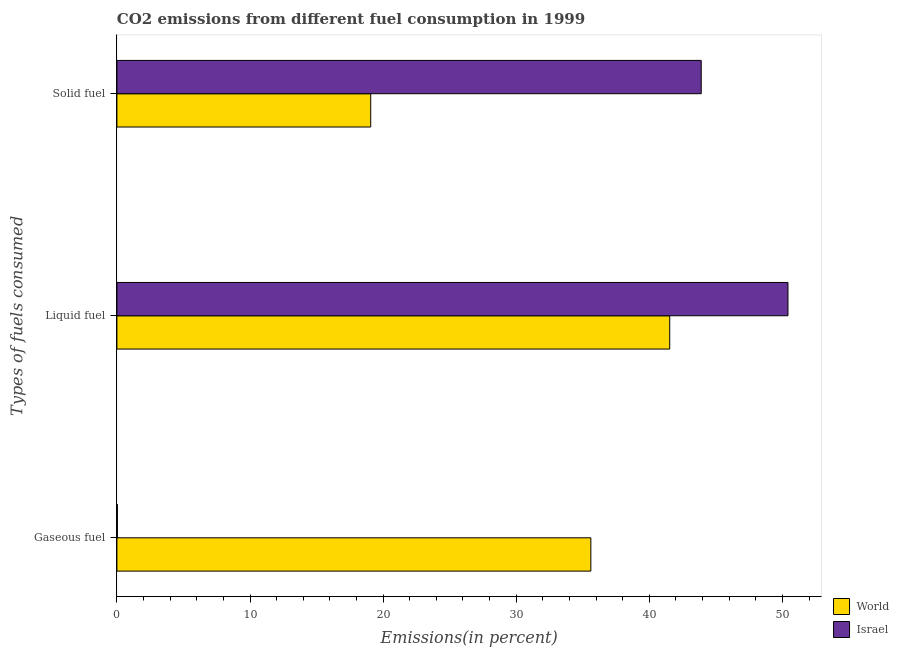How many groups of bars are there?
Offer a very short reply. 3. Are the number of bars per tick equal to the number of legend labels?
Provide a short and direct response. Yes. Are the number of bars on each tick of the Y-axis equal?
Keep it short and to the point. Yes. How many bars are there on the 1st tick from the top?
Make the answer very short. 2. How many bars are there on the 1st tick from the bottom?
Provide a succinct answer. 2. What is the label of the 1st group of bars from the top?
Provide a short and direct response. Solid fuel. What is the percentage of gaseous fuel emission in World?
Your response must be concise. 35.61. Across all countries, what is the maximum percentage of liquid fuel emission?
Give a very brief answer. 50.42. Across all countries, what is the minimum percentage of gaseous fuel emission?
Give a very brief answer. 0.03. In which country was the percentage of solid fuel emission maximum?
Your answer should be compact. Israel. What is the total percentage of gaseous fuel emission in the graph?
Offer a very short reply. 35.64. What is the difference between the percentage of solid fuel emission in World and that in Israel?
Your answer should be very brief. -24.83. What is the difference between the percentage of liquid fuel emission in World and the percentage of gaseous fuel emission in Israel?
Ensure brevity in your answer.  41.5. What is the average percentage of liquid fuel emission per country?
Your response must be concise. 45.98. What is the difference between the percentage of liquid fuel emission and percentage of gaseous fuel emission in Israel?
Ensure brevity in your answer.  50.39. What is the ratio of the percentage of solid fuel emission in Israel to that in World?
Offer a terse response. 2.3. Is the percentage of solid fuel emission in Israel less than that in World?
Your answer should be very brief. No. What is the difference between the highest and the second highest percentage of liquid fuel emission?
Your answer should be compact. 8.88. What is the difference between the highest and the lowest percentage of liquid fuel emission?
Provide a short and direct response. 8.88. In how many countries, is the percentage of solid fuel emission greater than the average percentage of solid fuel emission taken over all countries?
Your answer should be compact. 1. What does the 1st bar from the top in Liquid fuel represents?
Offer a terse response. Israel. What does the 1st bar from the bottom in Gaseous fuel represents?
Your answer should be very brief. World. Is it the case that in every country, the sum of the percentage of gaseous fuel emission and percentage of liquid fuel emission is greater than the percentage of solid fuel emission?
Your answer should be very brief. Yes. Are all the bars in the graph horizontal?
Offer a terse response. Yes. Are the values on the major ticks of X-axis written in scientific E-notation?
Make the answer very short. No. Does the graph contain any zero values?
Keep it short and to the point. No. Does the graph contain grids?
Offer a terse response. No. Where does the legend appear in the graph?
Keep it short and to the point. Bottom right. What is the title of the graph?
Provide a succinct answer. CO2 emissions from different fuel consumption in 1999. Does "Burundi" appear as one of the legend labels in the graph?
Your answer should be very brief. No. What is the label or title of the X-axis?
Offer a terse response. Emissions(in percent). What is the label or title of the Y-axis?
Ensure brevity in your answer.  Types of fuels consumed. What is the Emissions(in percent) of World in Gaseous fuel?
Your answer should be compact. 35.61. What is the Emissions(in percent) of Israel in Gaseous fuel?
Give a very brief answer. 0.03. What is the Emissions(in percent) of World in Liquid fuel?
Keep it short and to the point. 41.53. What is the Emissions(in percent) of Israel in Liquid fuel?
Give a very brief answer. 50.42. What is the Emissions(in percent) of World in Solid fuel?
Your response must be concise. 19.07. What is the Emissions(in percent) of Israel in Solid fuel?
Your answer should be very brief. 43.9. Across all Types of fuels consumed, what is the maximum Emissions(in percent) in World?
Ensure brevity in your answer.  41.53. Across all Types of fuels consumed, what is the maximum Emissions(in percent) in Israel?
Ensure brevity in your answer.  50.42. Across all Types of fuels consumed, what is the minimum Emissions(in percent) of World?
Ensure brevity in your answer.  19.07. Across all Types of fuels consumed, what is the minimum Emissions(in percent) of Israel?
Your answer should be compact. 0.03. What is the total Emissions(in percent) in World in the graph?
Your response must be concise. 96.21. What is the total Emissions(in percent) of Israel in the graph?
Offer a terse response. 94.35. What is the difference between the Emissions(in percent) of World in Gaseous fuel and that in Liquid fuel?
Your answer should be compact. -5.93. What is the difference between the Emissions(in percent) of Israel in Gaseous fuel and that in Liquid fuel?
Keep it short and to the point. -50.39. What is the difference between the Emissions(in percent) in World in Gaseous fuel and that in Solid fuel?
Provide a succinct answer. 16.54. What is the difference between the Emissions(in percent) in Israel in Gaseous fuel and that in Solid fuel?
Offer a very short reply. -43.87. What is the difference between the Emissions(in percent) in World in Liquid fuel and that in Solid fuel?
Offer a terse response. 22.46. What is the difference between the Emissions(in percent) of Israel in Liquid fuel and that in Solid fuel?
Provide a succinct answer. 6.52. What is the difference between the Emissions(in percent) of World in Gaseous fuel and the Emissions(in percent) of Israel in Liquid fuel?
Offer a terse response. -14.81. What is the difference between the Emissions(in percent) in World in Gaseous fuel and the Emissions(in percent) in Israel in Solid fuel?
Offer a very short reply. -8.29. What is the difference between the Emissions(in percent) of World in Liquid fuel and the Emissions(in percent) of Israel in Solid fuel?
Keep it short and to the point. -2.37. What is the average Emissions(in percent) in World per Types of fuels consumed?
Your answer should be compact. 32.07. What is the average Emissions(in percent) in Israel per Types of fuels consumed?
Provide a succinct answer. 31.45. What is the difference between the Emissions(in percent) in World and Emissions(in percent) in Israel in Gaseous fuel?
Give a very brief answer. 35.57. What is the difference between the Emissions(in percent) of World and Emissions(in percent) of Israel in Liquid fuel?
Ensure brevity in your answer.  -8.88. What is the difference between the Emissions(in percent) of World and Emissions(in percent) of Israel in Solid fuel?
Give a very brief answer. -24.83. What is the ratio of the Emissions(in percent) in World in Gaseous fuel to that in Liquid fuel?
Ensure brevity in your answer.  0.86. What is the ratio of the Emissions(in percent) in Israel in Gaseous fuel to that in Liquid fuel?
Ensure brevity in your answer.  0. What is the ratio of the Emissions(in percent) of World in Gaseous fuel to that in Solid fuel?
Your answer should be compact. 1.87. What is the ratio of the Emissions(in percent) in Israel in Gaseous fuel to that in Solid fuel?
Your response must be concise. 0. What is the ratio of the Emissions(in percent) of World in Liquid fuel to that in Solid fuel?
Make the answer very short. 2.18. What is the ratio of the Emissions(in percent) in Israel in Liquid fuel to that in Solid fuel?
Provide a succinct answer. 1.15. What is the difference between the highest and the second highest Emissions(in percent) in World?
Make the answer very short. 5.93. What is the difference between the highest and the second highest Emissions(in percent) of Israel?
Keep it short and to the point. 6.52. What is the difference between the highest and the lowest Emissions(in percent) in World?
Ensure brevity in your answer.  22.46. What is the difference between the highest and the lowest Emissions(in percent) in Israel?
Keep it short and to the point. 50.39. 